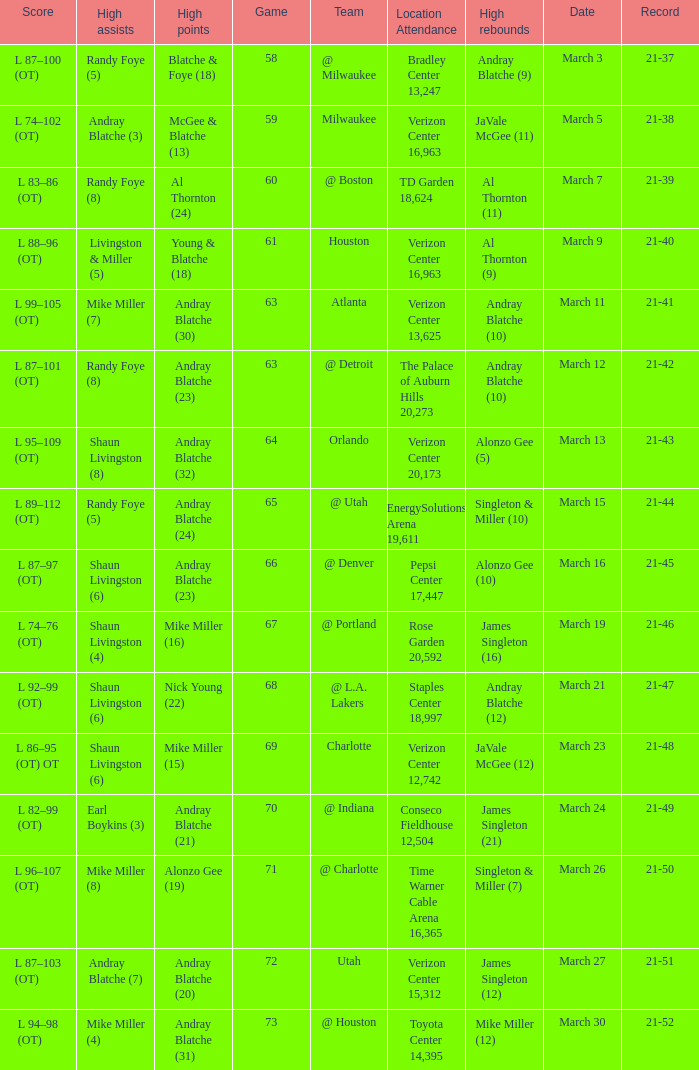On what date was the attendance at TD Garden 18,624? March 7. 